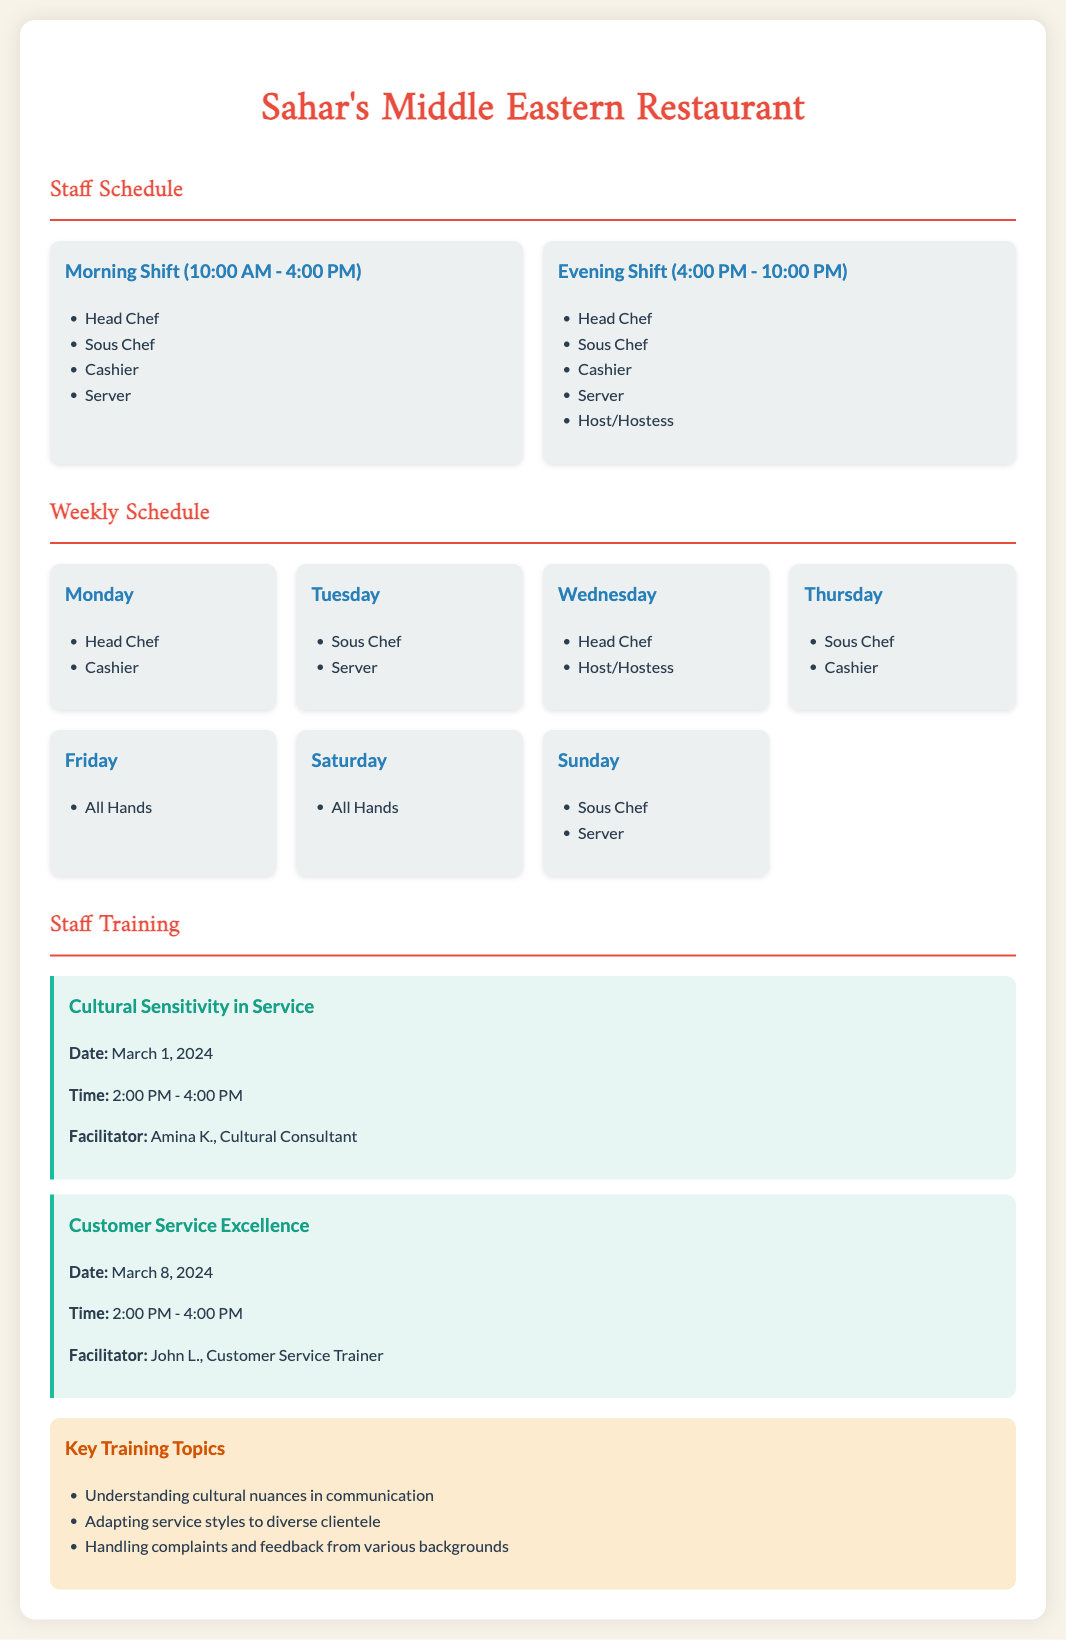what are the roles in the morning shift? The morning shift includes Head Chef, Sous Chef, Cashier, and Server.
Answer: Head Chef, Sous Chef, Cashier, Server how many training sessions are there? The document lists two training sessions for staff.
Answer: 2 what is the day of the first training session? The first training session on Cultural Sensitivity in Service is scheduled for March 1, 2024.
Answer: March 1, 2024 who is the facilitator for Customer Service Excellence? The document specifies John L. as the facilitator for this training session.
Answer: John L what is the shift time for the evening shift? The evening shift runs from 4:00 PM to 10:00 PM.
Answer: 4:00 PM - 10:00 PM which days have "All Hands" scheduled? Both Friday and Saturday are designated as "All Hands" days.
Answer: Friday, Saturday what is one key training topic? The document mentions understanding cultural nuances in communication as a key training topic.
Answer: Understanding cultural nuances in communication how many roles are listed for the evening shift? The evening shift consists of five roles as per the schedule.
Answer: 5 